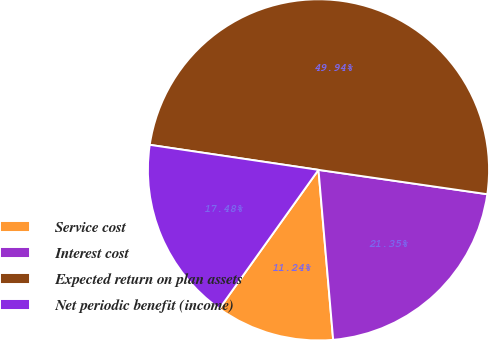Convert chart to OTSL. <chart><loc_0><loc_0><loc_500><loc_500><pie_chart><fcel>Service cost<fcel>Interest cost<fcel>Expected return on plan assets<fcel>Net periodic benefit (income)<nl><fcel>11.24%<fcel>21.35%<fcel>49.94%<fcel>17.48%<nl></chart> 